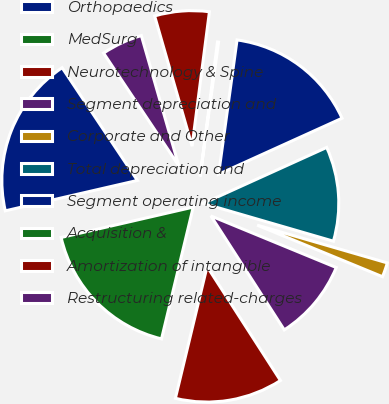Convert chart to OTSL. <chart><loc_0><loc_0><loc_500><loc_500><pie_chart><fcel>Orthopaedics<fcel>MedSurg<fcel>Neurotechnology & Spine<fcel>Segment depreciation and<fcel>Corporate and Other<fcel>Total depreciation and<fcel>Segment operating income<fcel>Acquisition &<fcel>Amortization of intangible<fcel>Restructuring related-charges<nl><fcel>19.23%<fcel>17.64%<fcel>12.86%<fcel>9.68%<fcel>1.72%<fcel>11.27%<fcel>16.05%<fcel>0.13%<fcel>6.5%<fcel>4.91%<nl></chart> 